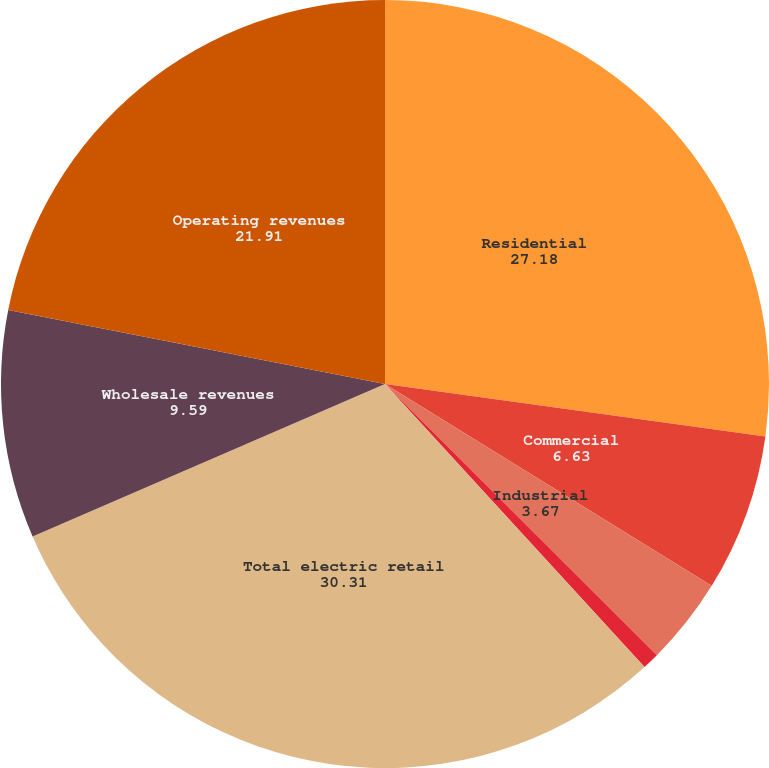Convert chart. <chart><loc_0><loc_0><loc_500><loc_500><pie_chart><fcel>Residential<fcel>Commercial<fcel>Industrial<fcel>Other retail revenues<fcel>Total electric retail<fcel>Wholesale revenues<fcel>Operating revenues<nl><fcel>27.18%<fcel>6.63%<fcel>3.67%<fcel>0.71%<fcel>30.31%<fcel>9.59%<fcel>21.91%<nl></chart> 